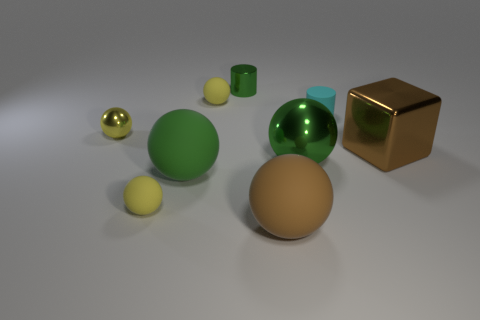What is the shape of the large metallic thing that is the same color as the tiny metal cylinder?
Keep it short and to the point. Sphere. Do the big brown block and the cylinder behind the tiny cyan rubber cylinder have the same material?
Provide a short and direct response. Yes. How many big brown matte spheres are behind the yellow object to the left of the tiny yellow matte ball in front of the cyan thing?
Your answer should be very brief. 0. How many gray objects are either small rubber objects or small cylinders?
Offer a very short reply. 0. What is the shape of the big matte object that is to the left of the small green cylinder?
Provide a succinct answer. Sphere. What is the color of the matte thing that is the same size as the brown rubber sphere?
Provide a succinct answer. Green. There is a big brown shiny object; is its shape the same as the large metal object that is on the left side of the cyan matte thing?
Keep it short and to the point. No. The tiny green cylinder that is to the right of the metal object to the left of the yellow matte sphere in front of the green metallic sphere is made of what material?
Give a very brief answer. Metal. What number of small objects are either brown things or purple cylinders?
Your answer should be compact. 0. What number of other objects are the same size as the metal block?
Provide a short and direct response. 3. 